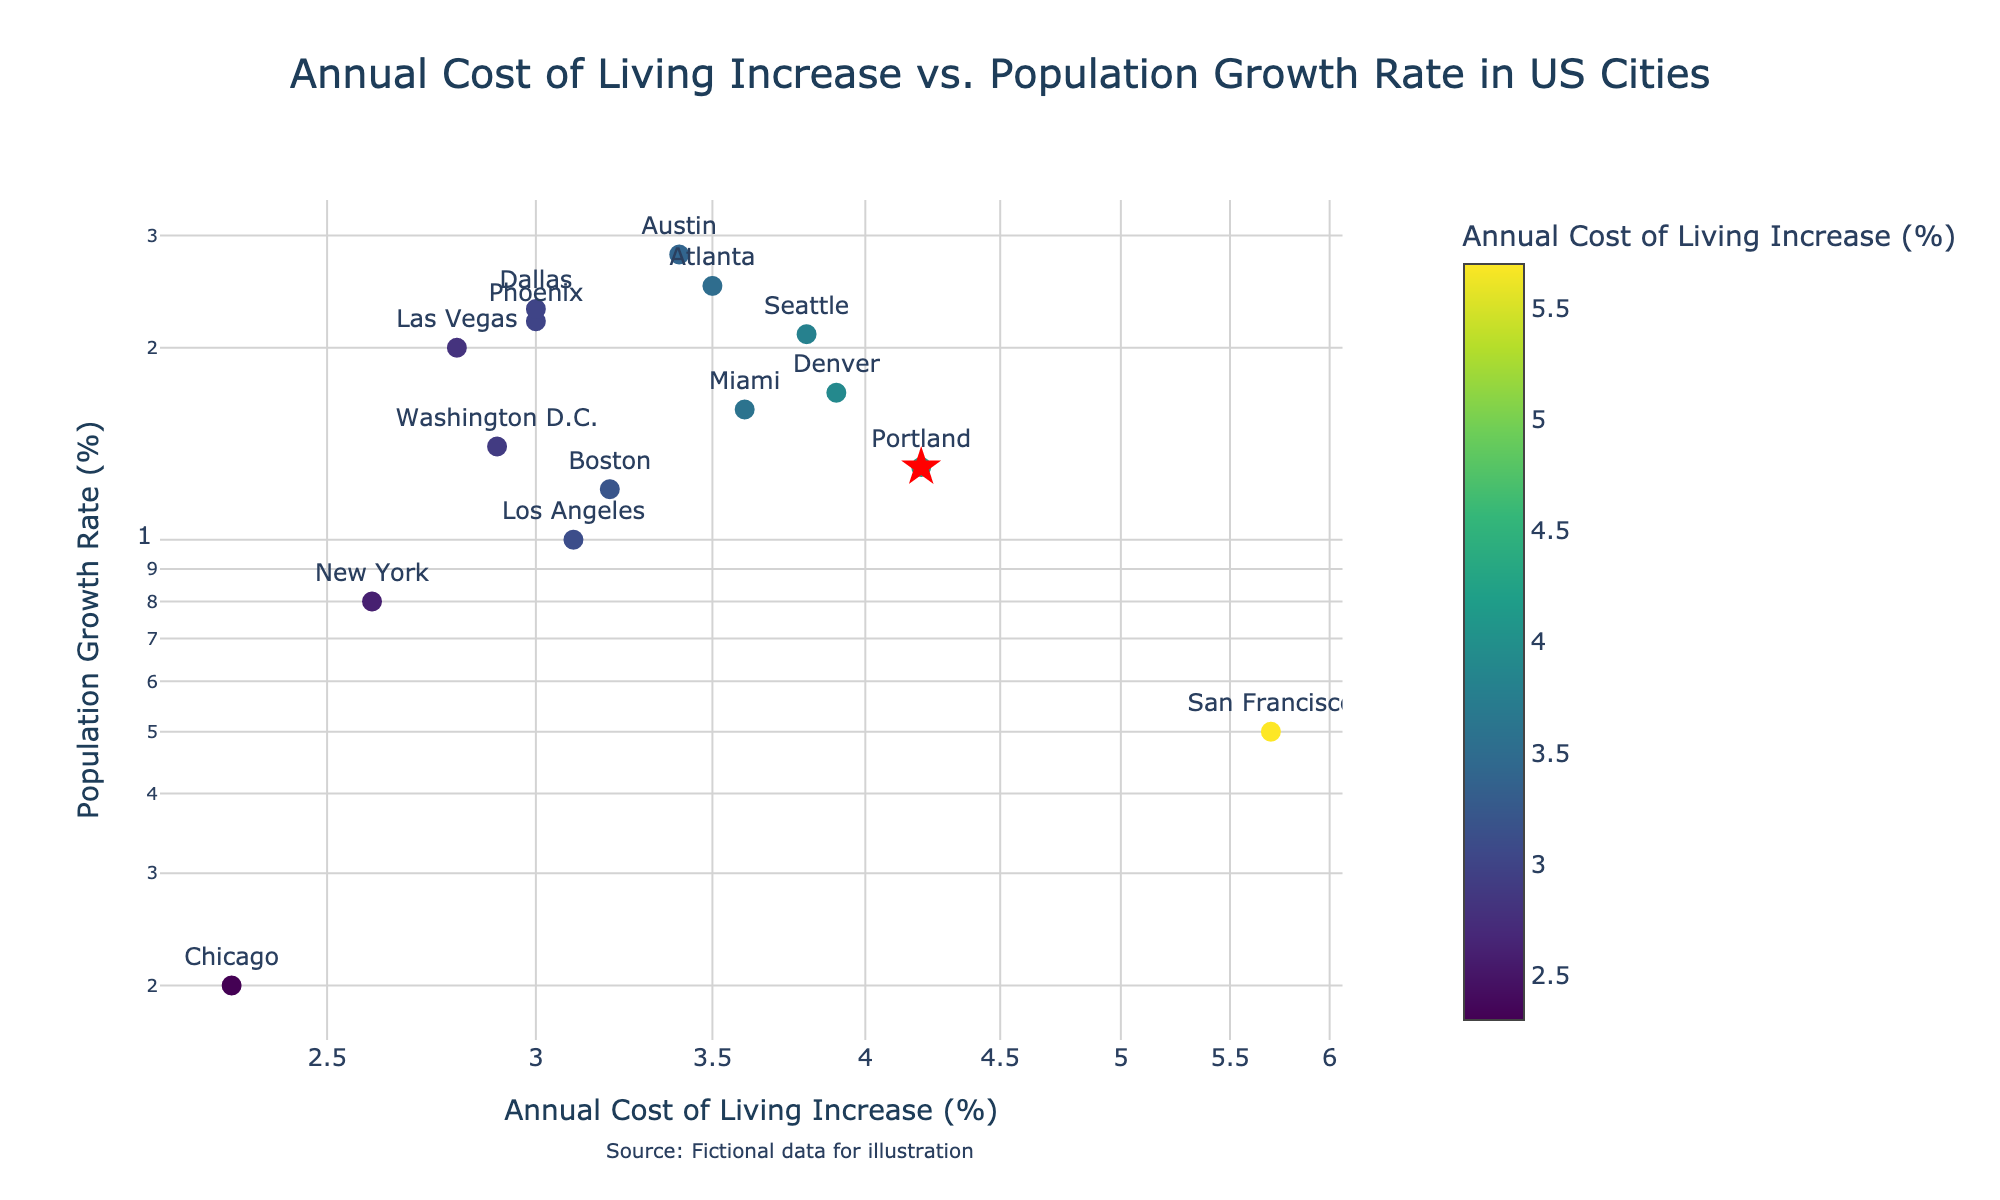How many cities are represented by data points in the figure? To find the number of cities, count the distinct markers shown in the scatter plot. Each marker represents a city.
Answer: 15 Which city has the highest Annual Cost of Living Increase? Look at the horizontal axis (log scale of Annual Cost of Living Increase) and identify the city whose marker is furthest to the right.
Answer: San Francisco Which city has the highest Population Growth Rate? Look at the vertical axis (log scale of Population Growth Rate) and identify the city whose marker is highest up on the plot.
Answer: Austin What is the estimated median Annual Cost of Living Increase among the cities shown? Order the annual cost of living increases from lowest to highest: 2.3, 2.6, 2.8, 2.9, 3.0, 3.0, 3.1, 3.2, 3.4, 3.5, 3.6, 3.8, 3.9, 4.2, 5.7. The median value is at the 8th position.
Answer: 3.2 Compare Portland and Seattle. Which city has a higher Population Growth Rate? Find the markers for Portland and Seattle by their labels and then compare their positions vertically on the plot.
Answer: Seattle How is Portland visually distinguished in the plot? Identify unique visual cues associated with Portland's marker, such as color, size, or shape.
Answer: Red star Which cities have a Population Growth Rate between 1.0% and 2.0%? Look at the vertical axis and identify cities whose markers fall within the given range.
Answer: Denver, Washington D.C., Miami, Boston, Los Angeles Is there a general trend between Annual Cost of Living Increase and Population Growth Rate? Observe the overall pattern of the markers in the scatter plot to determine if there's any observable trend in terms of direction or clustering.
Answer: No clear trend What is the range of Population Growth Rates among the cities with a Cost of Living Increase above 3.5%? Identify the cities with Annual Cost of Living Increase > 3.5%, then find the minimum and maximum Population Growth Rates among these cities.
Answer: 0.5% to 2.1% 